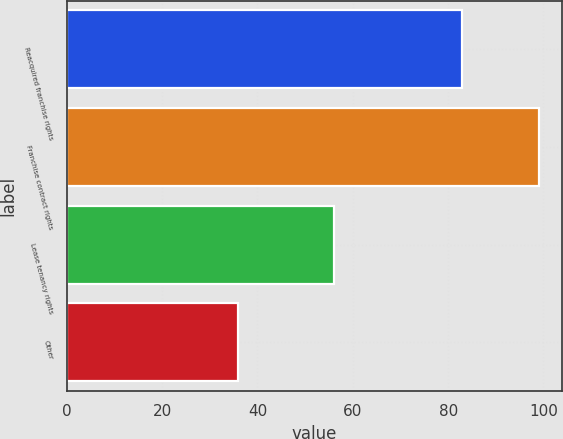Convert chart. <chart><loc_0><loc_0><loc_500><loc_500><bar_chart><fcel>Reacquired franchise rights<fcel>Franchise contract rights<fcel>Lease tenancy rights<fcel>Other<nl><fcel>83<fcel>99<fcel>56<fcel>36<nl></chart> 